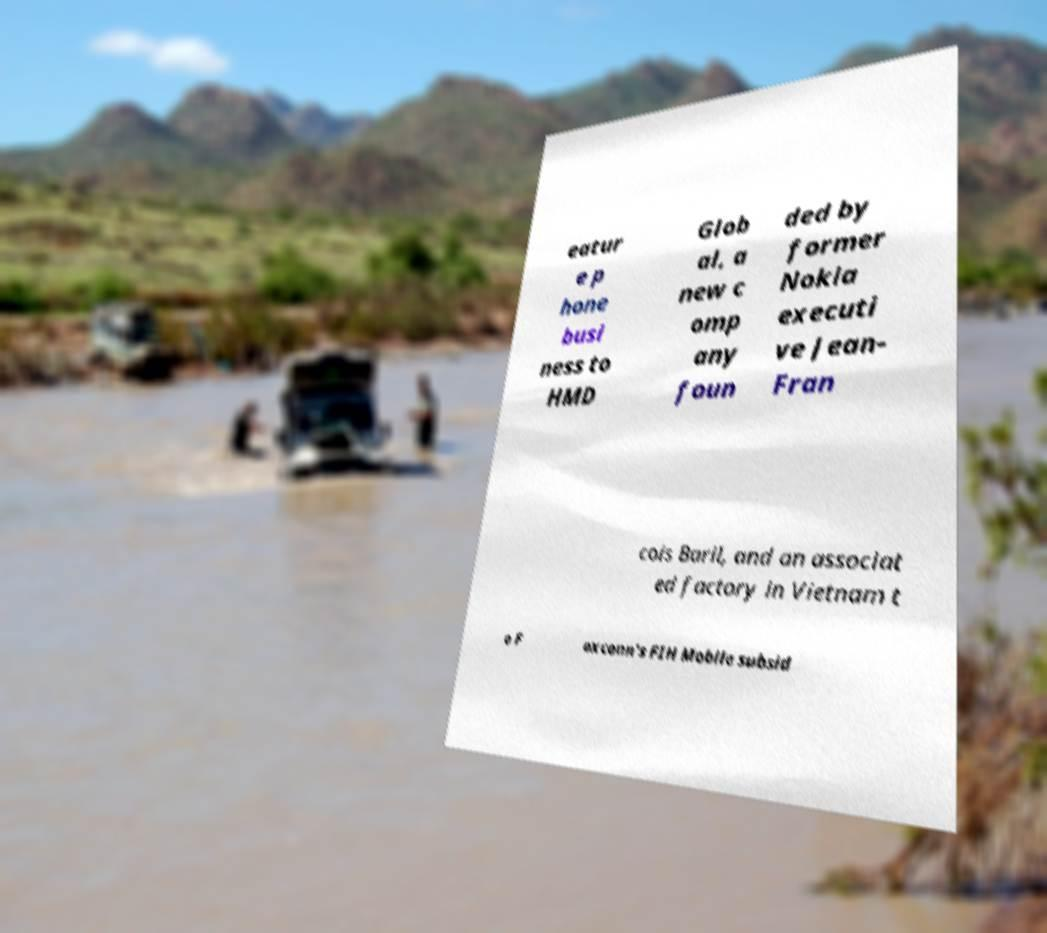What messages or text are displayed in this image? I need them in a readable, typed format. eatur e p hone busi ness to HMD Glob al, a new c omp any foun ded by former Nokia executi ve Jean- Fran cois Baril, and an associat ed factory in Vietnam t o F oxconn's FIH Mobile subsid 